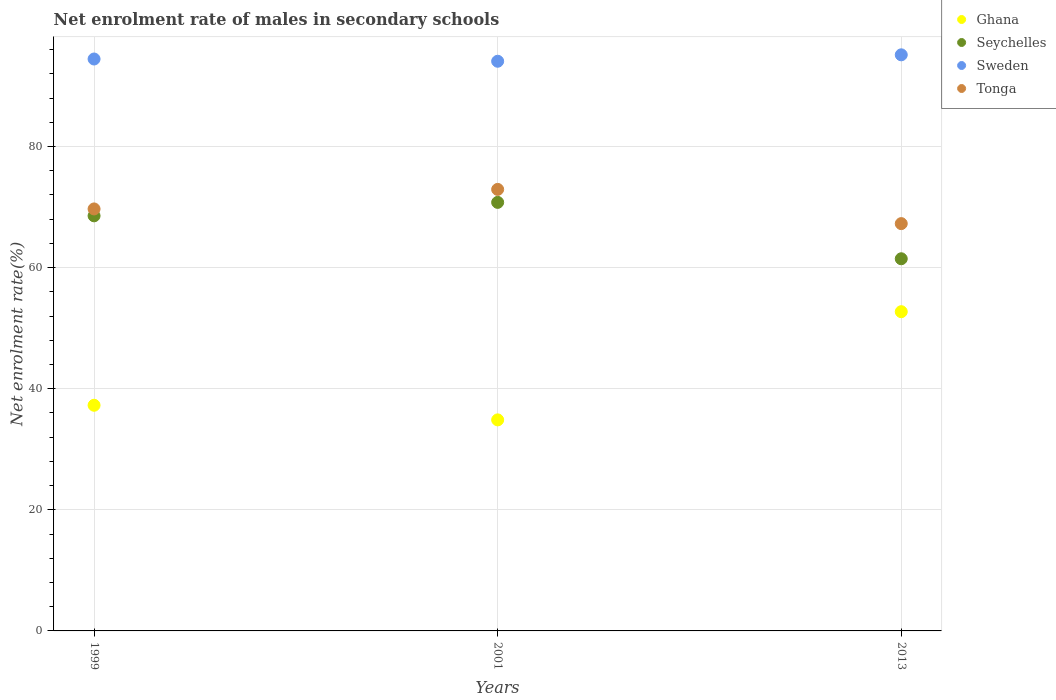What is the net enrolment rate of males in secondary schools in Ghana in 1999?
Provide a short and direct response. 37.27. Across all years, what is the maximum net enrolment rate of males in secondary schools in Sweden?
Provide a succinct answer. 95.14. Across all years, what is the minimum net enrolment rate of males in secondary schools in Tonga?
Provide a short and direct response. 67.27. What is the total net enrolment rate of males in secondary schools in Seychelles in the graph?
Your answer should be compact. 200.78. What is the difference between the net enrolment rate of males in secondary schools in Seychelles in 1999 and that in 2001?
Provide a short and direct response. -2.22. What is the difference between the net enrolment rate of males in secondary schools in Tonga in 2013 and the net enrolment rate of males in secondary schools in Ghana in 1999?
Keep it short and to the point. 30. What is the average net enrolment rate of males in secondary schools in Seychelles per year?
Keep it short and to the point. 66.93. In the year 2013, what is the difference between the net enrolment rate of males in secondary schools in Ghana and net enrolment rate of males in secondary schools in Sweden?
Provide a short and direct response. -42.42. In how many years, is the net enrolment rate of males in secondary schools in Ghana greater than 32 %?
Offer a terse response. 3. What is the ratio of the net enrolment rate of males in secondary schools in Tonga in 1999 to that in 2013?
Provide a succinct answer. 1.04. What is the difference between the highest and the second highest net enrolment rate of males in secondary schools in Ghana?
Ensure brevity in your answer.  15.45. What is the difference between the highest and the lowest net enrolment rate of males in secondary schools in Seychelles?
Your answer should be compact. 9.31. Is it the case that in every year, the sum of the net enrolment rate of males in secondary schools in Seychelles and net enrolment rate of males in secondary schools in Tonga  is greater than the net enrolment rate of males in secondary schools in Sweden?
Give a very brief answer. Yes. Is the net enrolment rate of males in secondary schools in Sweden strictly greater than the net enrolment rate of males in secondary schools in Seychelles over the years?
Offer a very short reply. Yes. How many dotlines are there?
Your response must be concise. 4. How many years are there in the graph?
Your response must be concise. 3. Are the values on the major ticks of Y-axis written in scientific E-notation?
Offer a terse response. No. Does the graph contain any zero values?
Your answer should be compact. No. Does the graph contain grids?
Offer a terse response. Yes. Where does the legend appear in the graph?
Give a very brief answer. Top right. How many legend labels are there?
Offer a terse response. 4. What is the title of the graph?
Offer a very short reply. Net enrolment rate of males in secondary schools. Does "Djibouti" appear as one of the legend labels in the graph?
Offer a very short reply. No. What is the label or title of the Y-axis?
Ensure brevity in your answer.  Net enrolment rate(%). What is the Net enrolment rate(%) of Ghana in 1999?
Provide a succinct answer. 37.27. What is the Net enrolment rate(%) in Seychelles in 1999?
Your response must be concise. 68.55. What is the Net enrolment rate(%) of Sweden in 1999?
Make the answer very short. 94.45. What is the Net enrolment rate(%) of Tonga in 1999?
Provide a short and direct response. 69.69. What is the Net enrolment rate(%) in Ghana in 2001?
Ensure brevity in your answer.  34.85. What is the Net enrolment rate(%) of Seychelles in 2001?
Offer a very short reply. 70.77. What is the Net enrolment rate(%) of Sweden in 2001?
Your answer should be compact. 94.08. What is the Net enrolment rate(%) in Tonga in 2001?
Offer a terse response. 72.92. What is the Net enrolment rate(%) in Ghana in 2013?
Provide a succinct answer. 52.72. What is the Net enrolment rate(%) of Seychelles in 2013?
Make the answer very short. 61.46. What is the Net enrolment rate(%) in Sweden in 2013?
Ensure brevity in your answer.  95.14. What is the Net enrolment rate(%) of Tonga in 2013?
Offer a terse response. 67.27. Across all years, what is the maximum Net enrolment rate(%) of Ghana?
Provide a succinct answer. 52.72. Across all years, what is the maximum Net enrolment rate(%) of Seychelles?
Offer a terse response. 70.77. Across all years, what is the maximum Net enrolment rate(%) of Sweden?
Make the answer very short. 95.14. Across all years, what is the maximum Net enrolment rate(%) in Tonga?
Offer a very short reply. 72.92. Across all years, what is the minimum Net enrolment rate(%) of Ghana?
Ensure brevity in your answer.  34.85. Across all years, what is the minimum Net enrolment rate(%) in Seychelles?
Provide a succinct answer. 61.46. Across all years, what is the minimum Net enrolment rate(%) of Sweden?
Provide a short and direct response. 94.08. Across all years, what is the minimum Net enrolment rate(%) in Tonga?
Give a very brief answer. 67.27. What is the total Net enrolment rate(%) in Ghana in the graph?
Provide a short and direct response. 124.84. What is the total Net enrolment rate(%) in Seychelles in the graph?
Provide a short and direct response. 200.78. What is the total Net enrolment rate(%) of Sweden in the graph?
Your answer should be very brief. 283.67. What is the total Net enrolment rate(%) in Tonga in the graph?
Provide a short and direct response. 209.88. What is the difference between the Net enrolment rate(%) of Ghana in 1999 and that in 2001?
Make the answer very short. 2.41. What is the difference between the Net enrolment rate(%) in Seychelles in 1999 and that in 2001?
Your answer should be very brief. -2.22. What is the difference between the Net enrolment rate(%) of Sweden in 1999 and that in 2001?
Your response must be concise. 0.37. What is the difference between the Net enrolment rate(%) of Tonga in 1999 and that in 2001?
Provide a short and direct response. -3.23. What is the difference between the Net enrolment rate(%) of Ghana in 1999 and that in 2013?
Your answer should be compact. -15.45. What is the difference between the Net enrolment rate(%) in Seychelles in 1999 and that in 2013?
Your response must be concise. 7.09. What is the difference between the Net enrolment rate(%) in Sweden in 1999 and that in 2013?
Keep it short and to the point. -0.69. What is the difference between the Net enrolment rate(%) of Tonga in 1999 and that in 2013?
Provide a succinct answer. 2.42. What is the difference between the Net enrolment rate(%) in Ghana in 2001 and that in 2013?
Provide a short and direct response. -17.87. What is the difference between the Net enrolment rate(%) in Seychelles in 2001 and that in 2013?
Provide a succinct answer. 9.31. What is the difference between the Net enrolment rate(%) of Sweden in 2001 and that in 2013?
Your response must be concise. -1.06. What is the difference between the Net enrolment rate(%) of Tonga in 2001 and that in 2013?
Ensure brevity in your answer.  5.65. What is the difference between the Net enrolment rate(%) in Ghana in 1999 and the Net enrolment rate(%) in Seychelles in 2001?
Ensure brevity in your answer.  -33.51. What is the difference between the Net enrolment rate(%) of Ghana in 1999 and the Net enrolment rate(%) of Sweden in 2001?
Provide a short and direct response. -56.81. What is the difference between the Net enrolment rate(%) of Ghana in 1999 and the Net enrolment rate(%) of Tonga in 2001?
Provide a succinct answer. -35.65. What is the difference between the Net enrolment rate(%) in Seychelles in 1999 and the Net enrolment rate(%) in Sweden in 2001?
Your answer should be compact. -25.53. What is the difference between the Net enrolment rate(%) of Seychelles in 1999 and the Net enrolment rate(%) of Tonga in 2001?
Your answer should be very brief. -4.37. What is the difference between the Net enrolment rate(%) of Sweden in 1999 and the Net enrolment rate(%) of Tonga in 2001?
Keep it short and to the point. 21.53. What is the difference between the Net enrolment rate(%) in Ghana in 1999 and the Net enrolment rate(%) in Seychelles in 2013?
Provide a succinct answer. -24.19. What is the difference between the Net enrolment rate(%) in Ghana in 1999 and the Net enrolment rate(%) in Sweden in 2013?
Offer a terse response. -57.87. What is the difference between the Net enrolment rate(%) in Ghana in 1999 and the Net enrolment rate(%) in Tonga in 2013?
Ensure brevity in your answer.  -30. What is the difference between the Net enrolment rate(%) of Seychelles in 1999 and the Net enrolment rate(%) of Sweden in 2013?
Your answer should be very brief. -26.59. What is the difference between the Net enrolment rate(%) in Seychelles in 1999 and the Net enrolment rate(%) in Tonga in 2013?
Give a very brief answer. 1.28. What is the difference between the Net enrolment rate(%) of Sweden in 1999 and the Net enrolment rate(%) of Tonga in 2013?
Provide a short and direct response. 27.18. What is the difference between the Net enrolment rate(%) in Ghana in 2001 and the Net enrolment rate(%) in Seychelles in 2013?
Offer a terse response. -26.61. What is the difference between the Net enrolment rate(%) in Ghana in 2001 and the Net enrolment rate(%) in Sweden in 2013?
Give a very brief answer. -60.29. What is the difference between the Net enrolment rate(%) of Ghana in 2001 and the Net enrolment rate(%) of Tonga in 2013?
Provide a short and direct response. -32.41. What is the difference between the Net enrolment rate(%) of Seychelles in 2001 and the Net enrolment rate(%) of Sweden in 2013?
Provide a succinct answer. -24.37. What is the difference between the Net enrolment rate(%) in Seychelles in 2001 and the Net enrolment rate(%) in Tonga in 2013?
Make the answer very short. 3.51. What is the difference between the Net enrolment rate(%) of Sweden in 2001 and the Net enrolment rate(%) of Tonga in 2013?
Provide a short and direct response. 26.81. What is the average Net enrolment rate(%) of Ghana per year?
Provide a succinct answer. 41.61. What is the average Net enrolment rate(%) in Seychelles per year?
Provide a short and direct response. 66.93. What is the average Net enrolment rate(%) of Sweden per year?
Keep it short and to the point. 94.56. What is the average Net enrolment rate(%) in Tonga per year?
Keep it short and to the point. 69.96. In the year 1999, what is the difference between the Net enrolment rate(%) of Ghana and Net enrolment rate(%) of Seychelles?
Provide a short and direct response. -31.28. In the year 1999, what is the difference between the Net enrolment rate(%) of Ghana and Net enrolment rate(%) of Sweden?
Your answer should be compact. -57.18. In the year 1999, what is the difference between the Net enrolment rate(%) in Ghana and Net enrolment rate(%) in Tonga?
Offer a very short reply. -32.42. In the year 1999, what is the difference between the Net enrolment rate(%) in Seychelles and Net enrolment rate(%) in Sweden?
Give a very brief answer. -25.9. In the year 1999, what is the difference between the Net enrolment rate(%) in Seychelles and Net enrolment rate(%) in Tonga?
Ensure brevity in your answer.  -1.14. In the year 1999, what is the difference between the Net enrolment rate(%) in Sweden and Net enrolment rate(%) in Tonga?
Offer a terse response. 24.76. In the year 2001, what is the difference between the Net enrolment rate(%) in Ghana and Net enrolment rate(%) in Seychelles?
Ensure brevity in your answer.  -35.92. In the year 2001, what is the difference between the Net enrolment rate(%) of Ghana and Net enrolment rate(%) of Sweden?
Provide a short and direct response. -59.23. In the year 2001, what is the difference between the Net enrolment rate(%) in Ghana and Net enrolment rate(%) in Tonga?
Your answer should be compact. -38.06. In the year 2001, what is the difference between the Net enrolment rate(%) in Seychelles and Net enrolment rate(%) in Sweden?
Make the answer very short. -23.31. In the year 2001, what is the difference between the Net enrolment rate(%) of Seychelles and Net enrolment rate(%) of Tonga?
Your answer should be compact. -2.15. In the year 2001, what is the difference between the Net enrolment rate(%) of Sweden and Net enrolment rate(%) of Tonga?
Keep it short and to the point. 21.16. In the year 2013, what is the difference between the Net enrolment rate(%) of Ghana and Net enrolment rate(%) of Seychelles?
Give a very brief answer. -8.74. In the year 2013, what is the difference between the Net enrolment rate(%) of Ghana and Net enrolment rate(%) of Sweden?
Offer a terse response. -42.42. In the year 2013, what is the difference between the Net enrolment rate(%) in Ghana and Net enrolment rate(%) in Tonga?
Provide a short and direct response. -14.55. In the year 2013, what is the difference between the Net enrolment rate(%) of Seychelles and Net enrolment rate(%) of Sweden?
Your response must be concise. -33.68. In the year 2013, what is the difference between the Net enrolment rate(%) in Seychelles and Net enrolment rate(%) in Tonga?
Your answer should be compact. -5.8. In the year 2013, what is the difference between the Net enrolment rate(%) of Sweden and Net enrolment rate(%) of Tonga?
Your response must be concise. 27.88. What is the ratio of the Net enrolment rate(%) of Ghana in 1999 to that in 2001?
Offer a terse response. 1.07. What is the ratio of the Net enrolment rate(%) of Seychelles in 1999 to that in 2001?
Ensure brevity in your answer.  0.97. What is the ratio of the Net enrolment rate(%) in Tonga in 1999 to that in 2001?
Make the answer very short. 0.96. What is the ratio of the Net enrolment rate(%) of Ghana in 1999 to that in 2013?
Give a very brief answer. 0.71. What is the ratio of the Net enrolment rate(%) in Seychelles in 1999 to that in 2013?
Keep it short and to the point. 1.12. What is the ratio of the Net enrolment rate(%) in Sweden in 1999 to that in 2013?
Provide a succinct answer. 0.99. What is the ratio of the Net enrolment rate(%) in Tonga in 1999 to that in 2013?
Your answer should be compact. 1.04. What is the ratio of the Net enrolment rate(%) of Ghana in 2001 to that in 2013?
Give a very brief answer. 0.66. What is the ratio of the Net enrolment rate(%) of Seychelles in 2001 to that in 2013?
Your answer should be very brief. 1.15. What is the ratio of the Net enrolment rate(%) of Sweden in 2001 to that in 2013?
Provide a short and direct response. 0.99. What is the ratio of the Net enrolment rate(%) in Tonga in 2001 to that in 2013?
Provide a succinct answer. 1.08. What is the difference between the highest and the second highest Net enrolment rate(%) in Ghana?
Your response must be concise. 15.45. What is the difference between the highest and the second highest Net enrolment rate(%) of Seychelles?
Provide a succinct answer. 2.22. What is the difference between the highest and the second highest Net enrolment rate(%) of Sweden?
Offer a very short reply. 0.69. What is the difference between the highest and the second highest Net enrolment rate(%) of Tonga?
Offer a terse response. 3.23. What is the difference between the highest and the lowest Net enrolment rate(%) in Ghana?
Give a very brief answer. 17.87. What is the difference between the highest and the lowest Net enrolment rate(%) of Seychelles?
Make the answer very short. 9.31. What is the difference between the highest and the lowest Net enrolment rate(%) in Sweden?
Your answer should be very brief. 1.06. What is the difference between the highest and the lowest Net enrolment rate(%) of Tonga?
Offer a terse response. 5.65. 